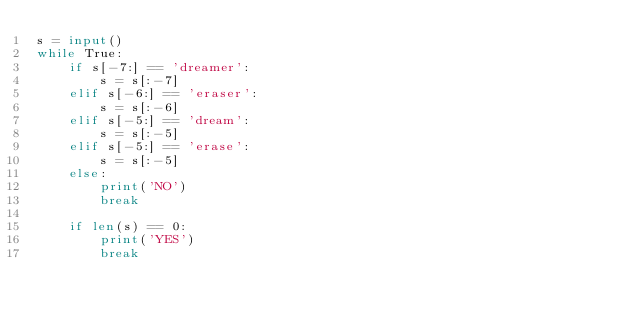<code> <loc_0><loc_0><loc_500><loc_500><_Python_>s = input()
while True:
    if s[-7:] == 'dreamer':
        s = s[:-7]
    elif s[-6:] == 'eraser':
        s = s[:-6]
    elif s[-5:] == 'dream':
        s = s[:-5]
    elif s[-5:] == 'erase':
        s = s[:-5]
    else:
        print('NO')
        break

    if len(s) == 0:
        print('YES')
        break
</code> 